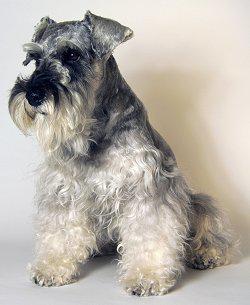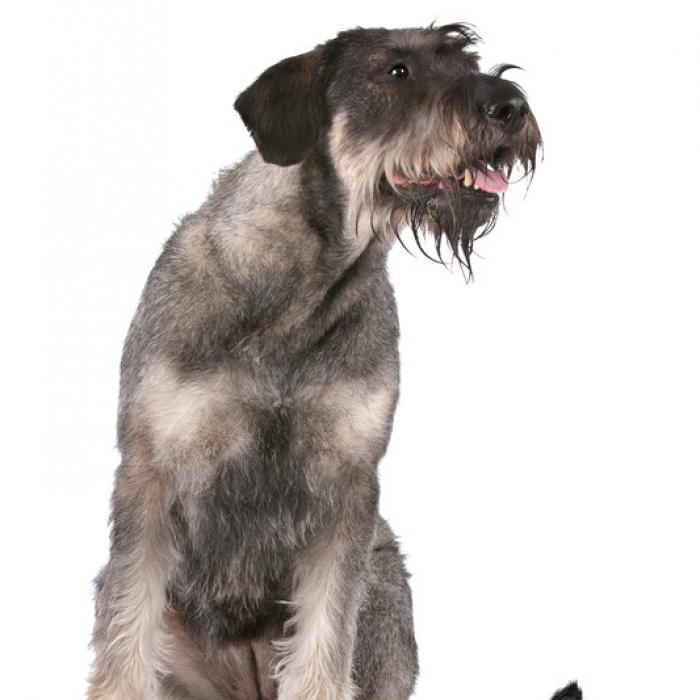The first image is the image on the left, the second image is the image on the right. For the images displayed, is the sentence "The dogs in the images are all looking straight ahead" factually correct? Answer yes or no. No. The first image is the image on the left, the second image is the image on the right. Analyze the images presented: Is the assertion "At least one of the dogs is directly on the grass." valid? Answer yes or no. No. 